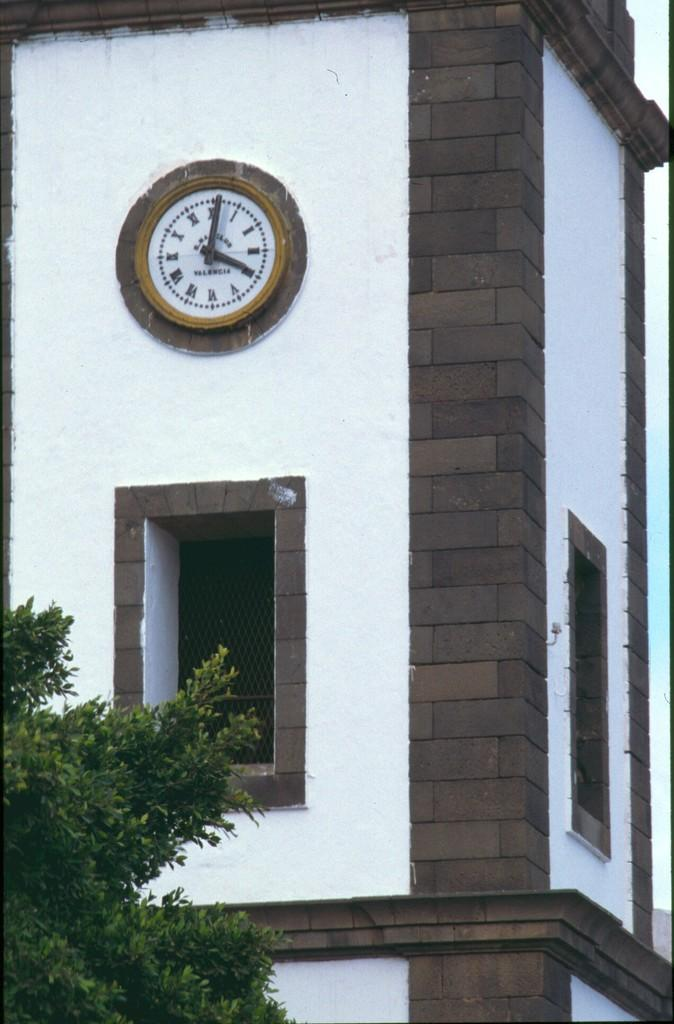What object is hanging on the wall in the image? There is a clock on the wall in the image. What type of natural element can be seen in the image? There is a tree visible in the image. How many wings can be seen on the tree in the image? There are no wings present in the image; it features a tree without any wings. What type of vegetable is growing on the wall next to the clock? There is no vegetable, specifically a potato, growing on the wall next to the clock in the image. 